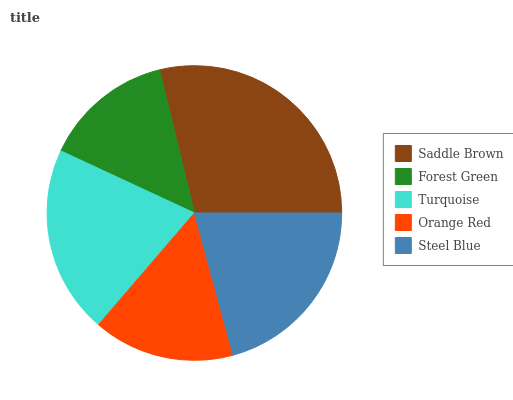Is Forest Green the minimum?
Answer yes or no. Yes. Is Saddle Brown the maximum?
Answer yes or no. Yes. Is Turquoise the minimum?
Answer yes or no. No. Is Turquoise the maximum?
Answer yes or no. No. Is Turquoise greater than Forest Green?
Answer yes or no. Yes. Is Forest Green less than Turquoise?
Answer yes or no. Yes. Is Forest Green greater than Turquoise?
Answer yes or no. No. Is Turquoise less than Forest Green?
Answer yes or no. No. Is Turquoise the high median?
Answer yes or no. Yes. Is Turquoise the low median?
Answer yes or no. Yes. Is Saddle Brown the high median?
Answer yes or no. No. Is Orange Red the low median?
Answer yes or no. No. 